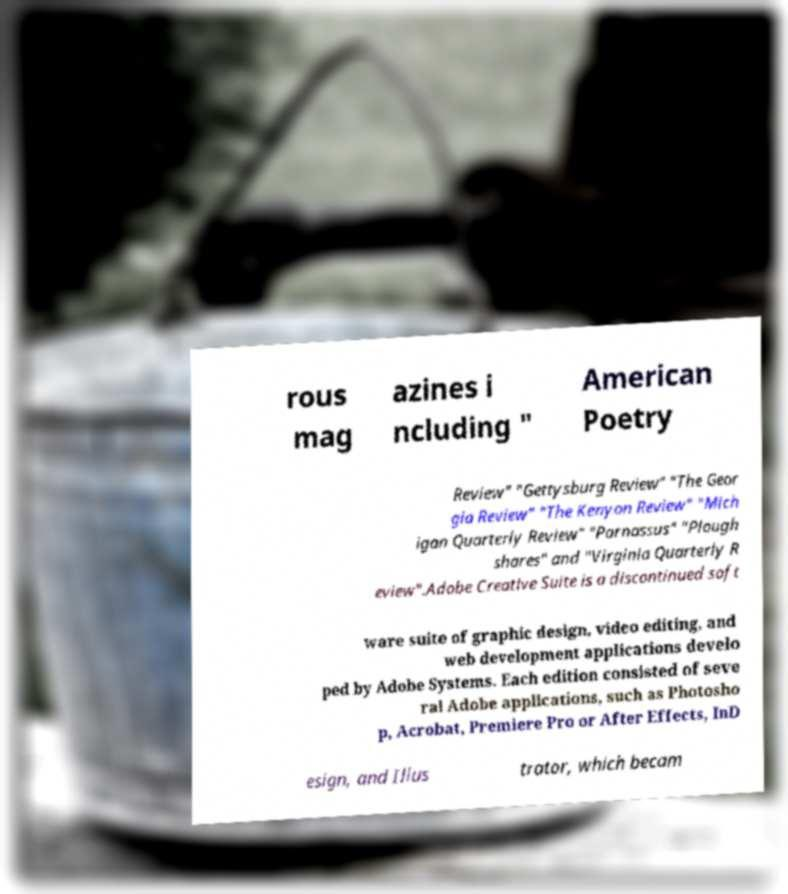Could you assist in decoding the text presented in this image and type it out clearly? rous mag azines i ncluding " American Poetry Review" "Gettysburg Review" "The Geor gia Review" "The Kenyon Review" "Mich igan Quarterly Review" "Parnassus" "Plough shares" and "Virginia Quarterly R eview".Adobe Creative Suite is a discontinued soft ware suite of graphic design, video editing, and web development applications develo ped by Adobe Systems. Each edition consisted of seve ral Adobe applications, such as Photosho p, Acrobat, Premiere Pro or After Effects, InD esign, and Illus trator, which becam 